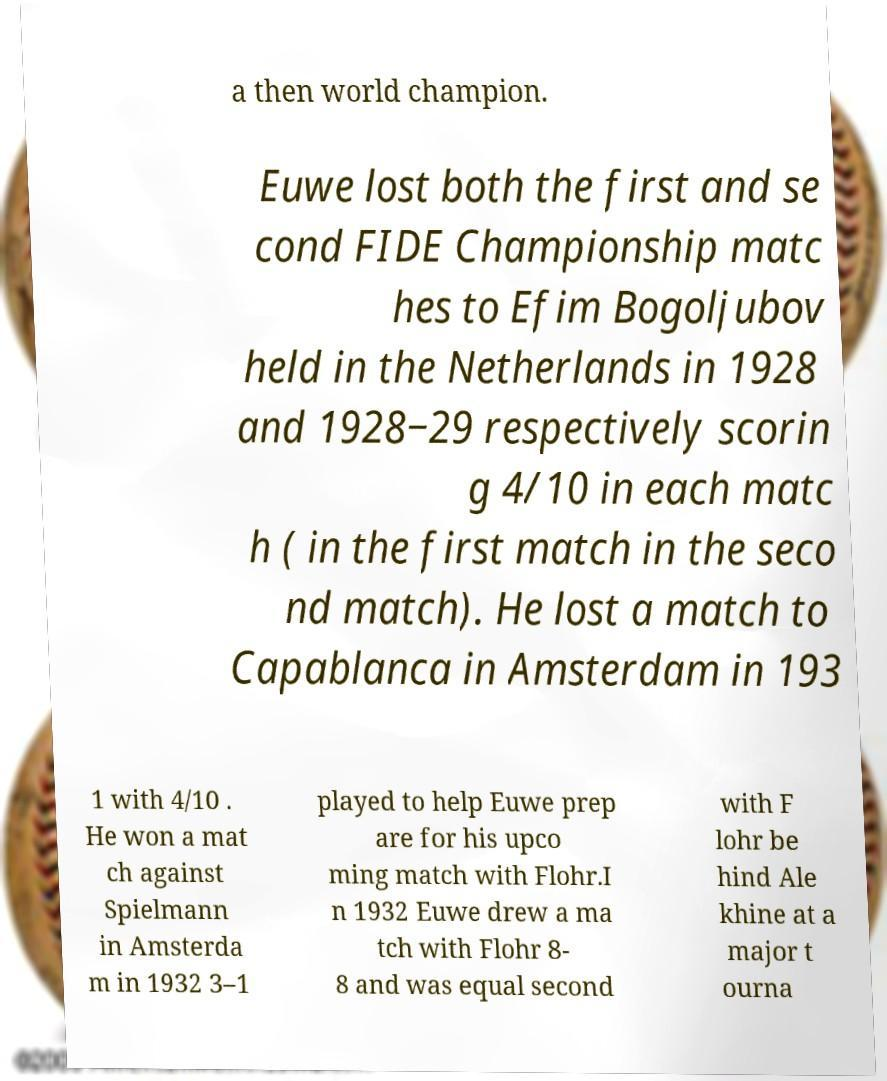There's text embedded in this image that I need extracted. Can you transcribe it verbatim? a then world champion. Euwe lost both the first and se cond FIDE Championship matc hes to Efim Bogoljubov held in the Netherlands in 1928 and 1928‒29 respectively scorin g 4/10 in each matc h ( in the first match in the seco nd match). He lost a match to Capablanca in Amsterdam in 193 1 with 4/10 . He won a mat ch against Spielmann in Amsterda m in 1932 3–1 played to help Euwe prep are for his upco ming match with Flohr.I n 1932 Euwe drew a ma tch with Flohr 8- 8 and was equal second with F lohr be hind Ale khine at a major t ourna 